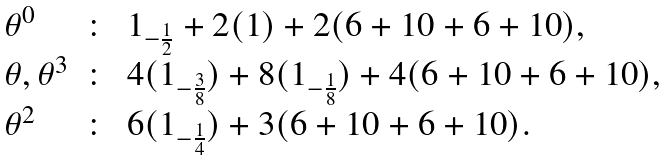<formula> <loc_0><loc_0><loc_500><loc_500>\begin{array} { l c l } \theta ^ { 0 } & \colon & 1 _ { - \frac { 1 } { 2 } } + 2 ( 1 ) + 2 ( 6 + 1 0 + 6 + 1 0 ) , \\ \theta , \theta ^ { 3 } & \colon & 4 ( 1 _ { - \frac { 3 } { 8 } } ) + 8 ( 1 _ { - \frac { 1 } { 8 } } ) + 4 ( 6 + 1 0 + 6 + 1 0 ) , \\ \theta ^ { 2 } & \colon & 6 ( 1 _ { - \frac { 1 } { 4 } } ) + 3 ( 6 + 1 0 + 6 + 1 0 ) . \end{array}</formula> 